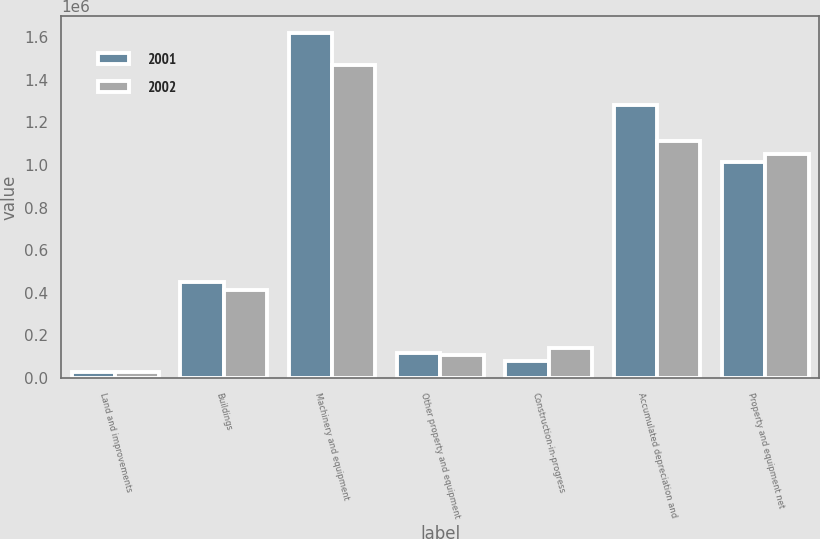Convert chart. <chart><loc_0><loc_0><loc_500><loc_500><stacked_bar_chart><ecel><fcel>Land and improvements<fcel>Buildings<fcel>Machinery and equipment<fcel>Other property and equipment<fcel>Construction-in-progress<fcel>Accumulated depreciation and<fcel>Property and equipment net<nl><fcel>2001<fcel>27335<fcel>449945<fcel>1.61603e+06<fcel>119592<fcel>79560<fcel>1.27944e+06<fcel>1.01302e+06<nl><fcel>2002<fcel>29784<fcel>413320<fcel>1.46695e+06<fcel>110666<fcel>139448<fcel>1.10973e+06<fcel>1.05044e+06<nl></chart> 